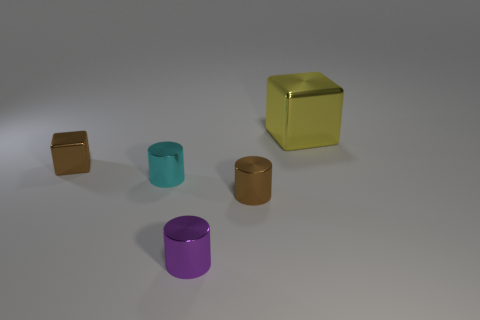Add 3 small purple metal cylinders. How many objects exist? 8 Subtract all cubes. How many objects are left? 3 Subtract 0 green cylinders. How many objects are left? 5 Subtract all small blue spheres. Subtract all purple metal cylinders. How many objects are left? 4 Add 4 cyan cylinders. How many cyan cylinders are left? 5 Add 5 tiny cyan metal objects. How many tiny cyan metal objects exist? 6 